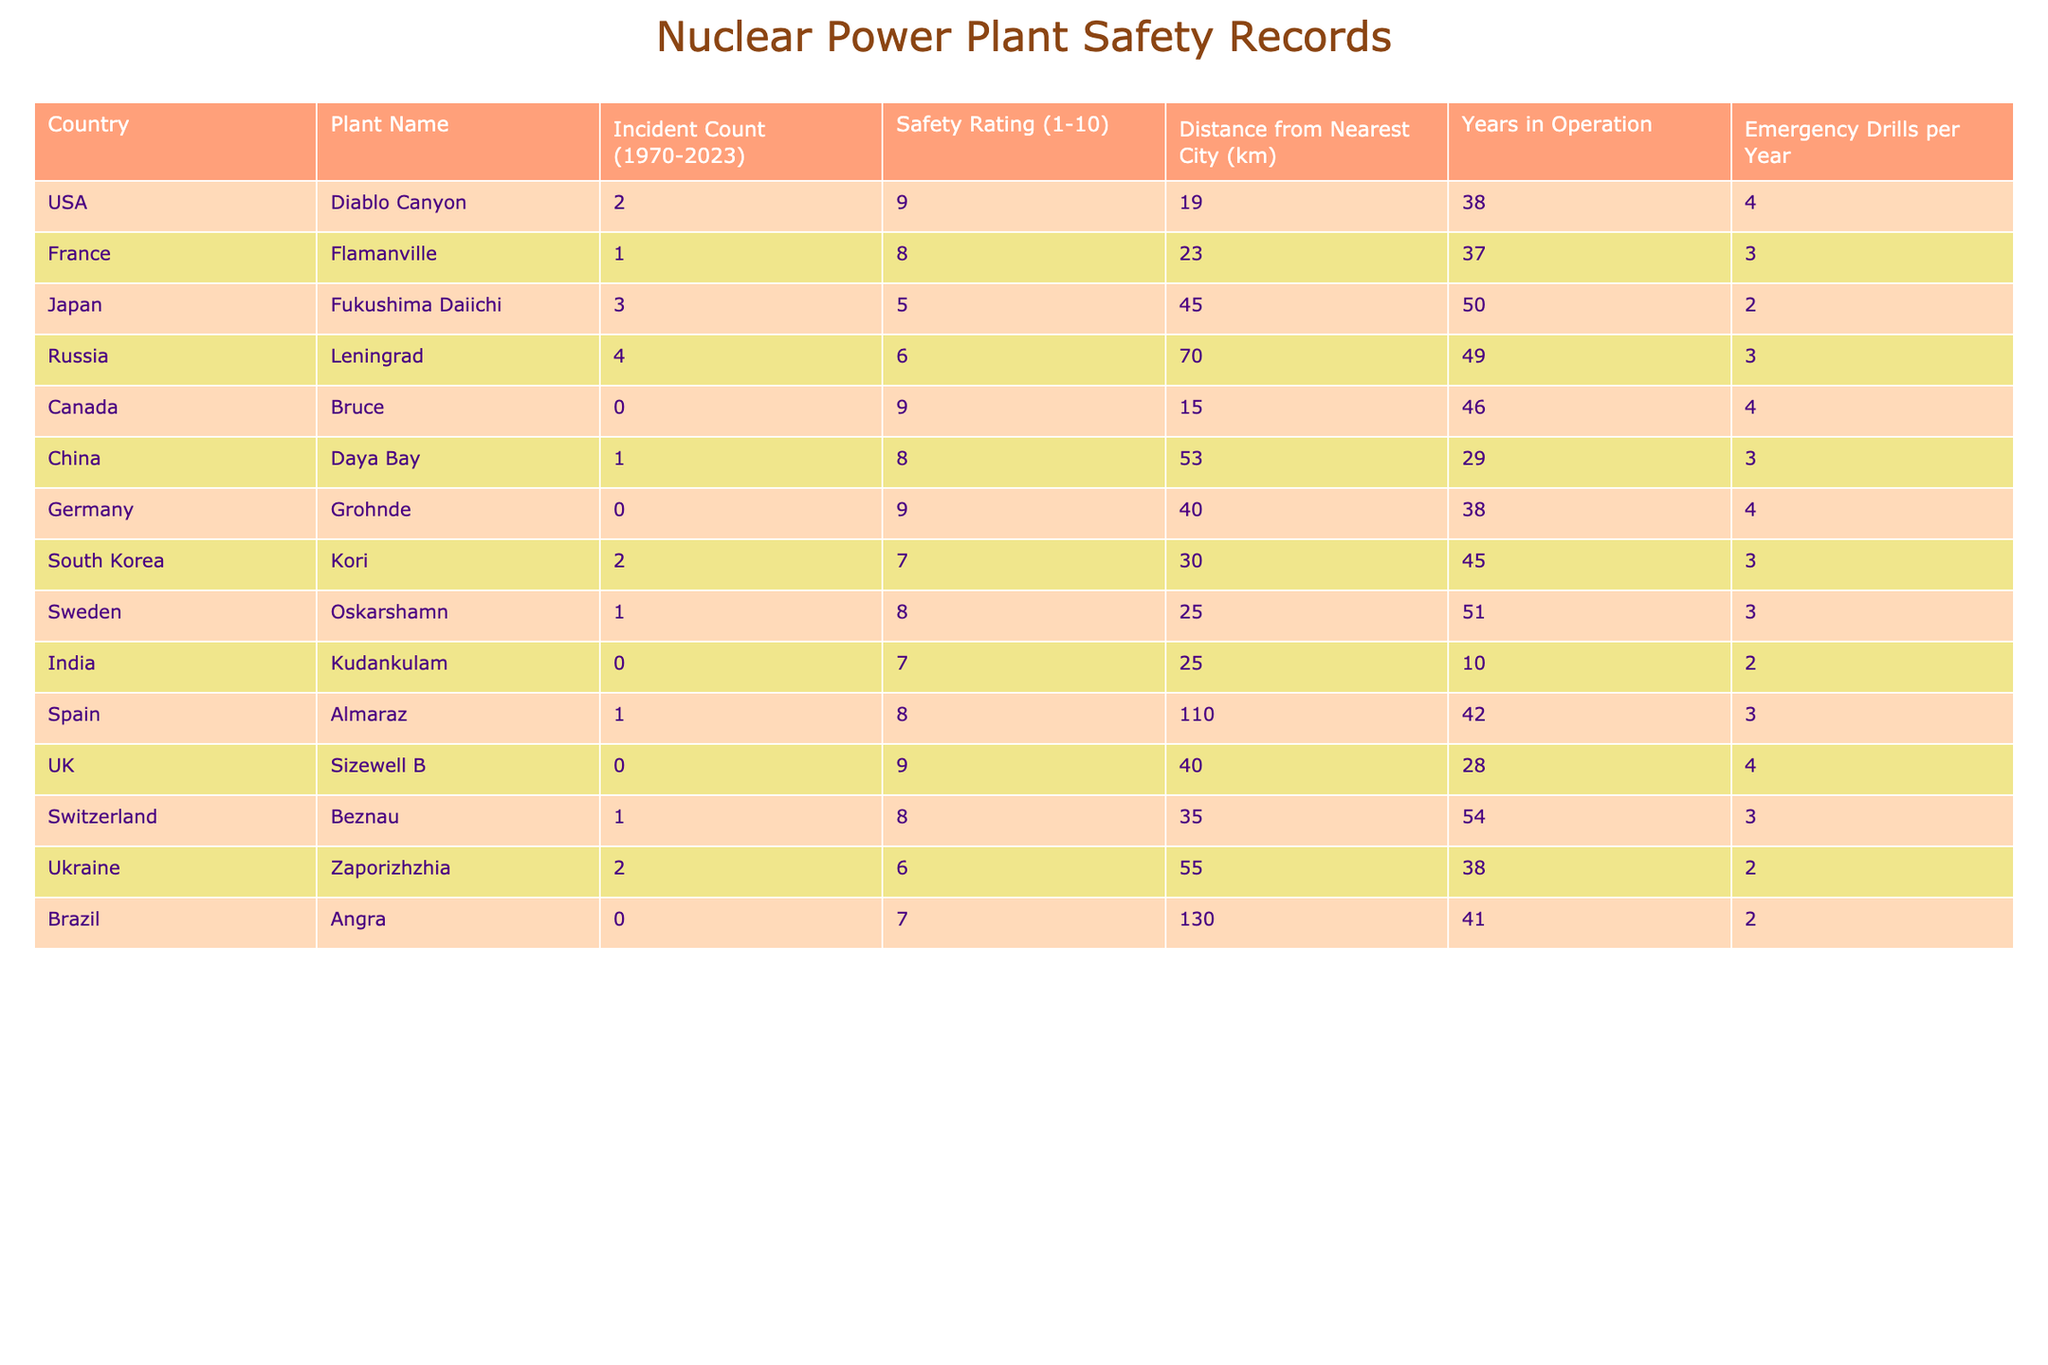What is the highest safety rating among the nuclear power plants listed? Upon examining the safety ratings column in the table, the highest safety rating is 9. Two plants, Diablo Canyon, Bruce, and Sizewell B, both have this rating.
Answer: 9 Which country has the nuclear power plant with the lowest incident count? Looking at the incident count column, Bruce in Canada has an incident count of 0, indicating it has the lowest.
Answer: Canada How many years has the Fukushima Daiichi plant been in operation? The table lists the years in operation for Fukushima Daiichi as 50.
Answer: 50 What is the average incident count for plants in the USA? The incident counts for USA plants (Diablo Canyon) are 2. There is only one plant, so the average incident count is 2/1 = 2.
Answer: 2 Which plant is the farthest from the nearest city, and how far is it? By reviewing the distance from the nearest city column, Almaraz in Spain is the farthest at 110 km.
Answer: Almaraz, 110 km Do any plants have a safety rating of 10? No plants listed in the table have a safety rating of 10, as the highest rating is 9.
Answer: No What is the total number of incident counts for all the plants listed? To find the total, we sum the incident counts: 2 + 1 + 3 + 4 + 0 + 1 + 0 + 2 + 1 + 0 + 1 + 2 + 0 = 17.
Answer: 17 Which country has the highest average safety rating based on the given information, and what is that rating? Analyzing the safety ratings for each country, with a maximum rating of 9 for the USA and Canada, we find the highest average safety rating is 9.
Answer: USA and Canada, 9 Are there any plants that conduct emergency drills more than 4 times a year? According to the table, all listed plants have emergency drills ranging from 2 to 4 drills per year, with none exceeding 4.
Answer: No How does the incident count of Fukushima Daiichi compare to the average incident count of all plants? The average incident count calculated is 17 total incidents divided by 14 plants = 1.21. Comparing Fukushima’s count of 3 to this average shows it is above average: 3 > 1.21.
Answer: Above average 